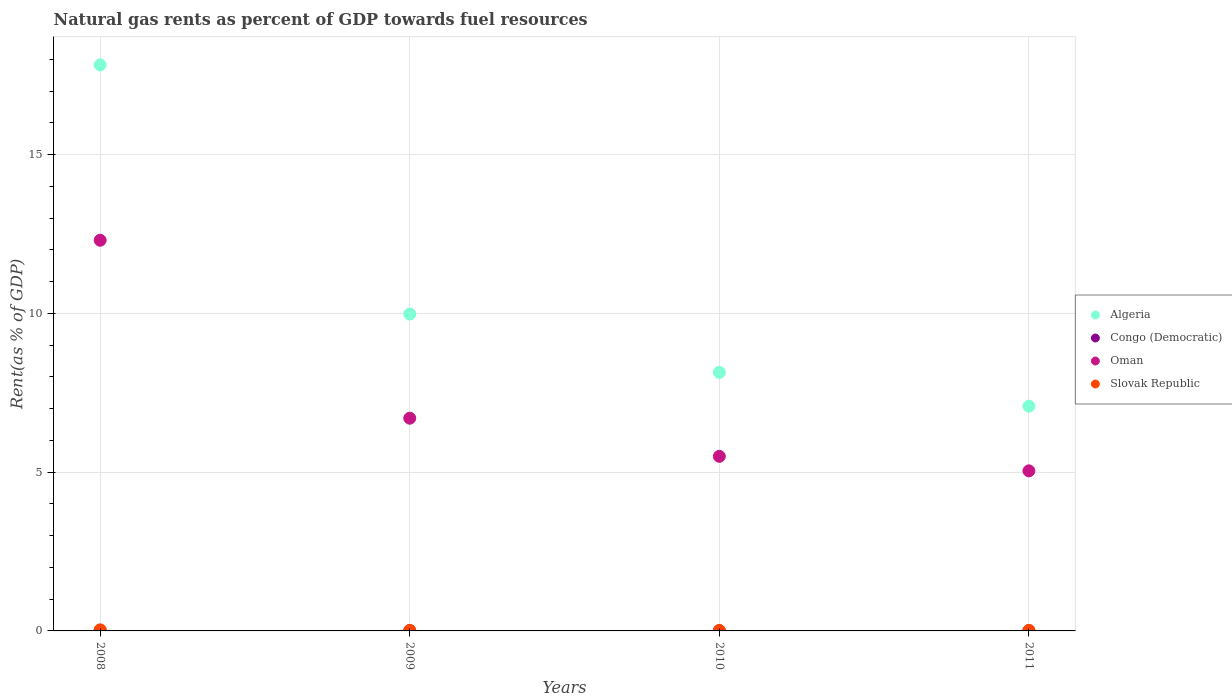What is the matural gas rent in Algeria in 2009?
Offer a very short reply. 9.98. Across all years, what is the maximum matural gas rent in Congo (Democratic)?
Ensure brevity in your answer.  0.02. Across all years, what is the minimum matural gas rent in Congo (Democratic)?
Ensure brevity in your answer.  0.01. In which year was the matural gas rent in Algeria minimum?
Your answer should be very brief. 2011. What is the total matural gas rent in Oman in the graph?
Make the answer very short. 29.54. What is the difference between the matural gas rent in Oman in 2008 and that in 2011?
Offer a very short reply. 7.26. What is the difference between the matural gas rent in Congo (Democratic) in 2011 and the matural gas rent in Algeria in 2008?
Give a very brief answer. -17.82. What is the average matural gas rent in Slovak Republic per year?
Your answer should be very brief. 0.02. In the year 2009, what is the difference between the matural gas rent in Slovak Republic and matural gas rent in Algeria?
Your answer should be compact. -9.96. In how many years, is the matural gas rent in Algeria greater than 1 %?
Provide a short and direct response. 4. What is the ratio of the matural gas rent in Congo (Democratic) in 2008 to that in 2011?
Make the answer very short. 2.58. Is the difference between the matural gas rent in Slovak Republic in 2008 and 2010 greater than the difference between the matural gas rent in Algeria in 2008 and 2010?
Keep it short and to the point. No. What is the difference between the highest and the second highest matural gas rent in Algeria?
Offer a terse response. 7.85. What is the difference between the highest and the lowest matural gas rent in Oman?
Give a very brief answer. 7.26. In how many years, is the matural gas rent in Congo (Democratic) greater than the average matural gas rent in Congo (Democratic) taken over all years?
Make the answer very short. 1. Does the matural gas rent in Congo (Democratic) monotonically increase over the years?
Your answer should be very brief. No. Is the matural gas rent in Oman strictly greater than the matural gas rent in Congo (Democratic) over the years?
Offer a terse response. Yes. Is the matural gas rent in Oman strictly less than the matural gas rent in Algeria over the years?
Your response must be concise. Yes. How many dotlines are there?
Your response must be concise. 4. What is the difference between two consecutive major ticks on the Y-axis?
Your answer should be very brief. 5. Are the values on the major ticks of Y-axis written in scientific E-notation?
Ensure brevity in your answer.  No. Does the graph contain any zero values?
Your response must be concise. No. Where does the legend appear in the graph?
Keep it short and to the point. Center right. What is the title of the graph?
Keep it short and to the point. Natural gas rents as percent of GDP towards fuel resources. What is the label or title of the X-axis?
Give a very brief answer. Years. What is the label or title of the Y-axis?
Offer a terse response. Rent(as % of GDP). What is the Rent(as % of GDP) in Algeria in 2008?
Make the answer very short. 17.82. What is the Rent(as % of GDP) in Congo (Democratic) in 2008?
Keep it short and to the point. 0.02. What is the Rent(as % of GDP) in Oman in 2008?
Offer a very short reply. 12.3. What is the Rent(as % of GDP) of Slovak Republic in 2008?
Provide a short and direct response. 0.03. What is the Rent(as % of GDP) of Algeria in 2009?
Your answer should be compact. 9.98. What is the Rent(as % of GDP) in Congo (Democratic) in 2009?
Provide a succinct answer. 0.01. What is the Rent(as % of GDP) in Oman in 2009?
Give a very brief answer. 6.7. What is the Rent(as % of GDP) in Slovak Republic in 2009?
Offer a very short reply. 0.02. What is the Rent(as % of GDP) in Algeria in 2010?
Keep it short and to the point. 8.14. What is the Rent(as % of GDP) in Congo (Democratic) in 2010?
Make the answer very short. 0.01. What is the Rent(as % of GDP) of Oman in 2010?
Provide a short and direct response. 5.5. What is the Rent(as % of GDP) of Slovak Republic in 2010?
Give a very brief answer. 0.01. What is the Rent(as % of GDP) in Algeria in 2011?
Ensure brevity in your answer.  7.08. What is the Rent(as % of GDP) in Congo (Democratic) in 2011?
Ensure brevity in your answer.  0.01. What is the Rent(as % of GDP) of Oman in 2011?
Offer a terse response. 5.04. What is the Rent(as % of GDP) in Slovak Republic in 2011?
Your answer should be compact. 0.02. Across all years, what is the maximum Rent(as % of GDP) of Algeria?
Your answer should be compact. 17.82. Across all years, what is the maximum Rent(as % of GDP) in Congo (Democratic)?
Ensure brevity in your answer.  0.02. Across all years, what is the maximum Rent(as % of GDP) in Oman?
Ensure brevity in your answer.  12.3. Across all years, what is the maximum Rent(as % of GDP) of Slovak Republic?
Offer a terse response. 0.03. Across all years, what is the minimum Rent(as % of GDP) of Algeria?
Your answer should be compact. 7.08. Across all years, what is the minimum Rent(as % of GDP) in Congo (Democratic)?
Make the answer very short. 0.01. Across all years, what is the minimum Rent(as % of GDP) of Oman?
Make the answer very short. 5.04. Across all years, what is the minimum Rent(as % of GDP) of Slovak Republic?
Your answer should be very brief. 0.01. What is the total Rent(as % of GDP) of Algeria in the graph?
Provide a succinct answer. 43.02. What is the total Rent(as % of GDP) of Congo (Democratic) in the graph?
Your answer should be very brief. 0.03. What is the total Rent(as % of GDP) of Oman in the graph?
Your response must be concise. 29.54. What is the total Rent(as % of GDP) in Slovak Republic in the graph?
Offer a terse response. 0.08. What is the difference between the Rent(as % of GDP) of Algeria in 2008 and that in 2009?
Provide a short and direct response. 7.85. What is the difference between the Rent(as % of GDP) of Congo (Democratic) in 2008 and that in 2009?
Provide a short and direct response. 0.01. What is the difference between the Rent(as % of GDP) of Oman in 2008 and that in 2009?
Provide a short and direct response. 5.6. What is the difference between the Rent(as % of GDP) in Slovak Republic in 2008 and that in 2009?
Make the answer very short. 0.02. What is the difference between the Rent(as % of GDP) in Algeria in 2008 and that in 2010?
Offer a terse response. 9.68. What is the difference between the Rent(as % of GDP) in Congo (Democratic) in 2008 and that in 2010?
Keep it short and to the point. 0.01. What is the difference between the Rent(as % of GDP) of Oman in 2008 and that in 2010?
Keep it short and to the point. 6.8. What is the difference between the Rent(as % of GDP) in Slovak Republic in 2008 and that in 2010?
Your answer should be very brief. 0.02. What is the difference between the Rent(as % of GDP) in Algeria in 2008 and that in 2011?
Provide a succinct answer. 10.75. What is the difference between the Rent(as % of GDP) of Congo (Democratic) in 2008 and that in 2011?
Offer a terse response. 0.01. What is the difference between the Rent(as % of GDP) of Oman in 2008 and that in 2011?
Provide a succinct answer. 7.26. What is the difference between the Rent(as % of GDP) in Slovak Republic in 2008 and that in 2011?
Offer a terse response. 0.02. What is the difference between the Rent(as % of GDP) of Algeria in 2009 and that in 2010?
Offer a terse response. 1.84. What is the difference between the Rent(as % of GDP) of Congo (Democratic) in 2009 and that in 2010?
Your answer should be compact. 0. What is the difference between the Rent(as % of GDP) of Oman in 2009 and that in 2010?
Give a very brief answer. 1.2. What is the difference between the Rent(as % of GDP) of Slovak Republic in 2009 and that in 2010?
Your answer should be compact. 0. What is the difference between the Rent(as % of GDP) of Algeria in 2009 and that in 2011?
Make the answer very short. 2.9. What is the difference between the Rent(as % of GDP) in Congo (Democratic) in 2009 and that in 2011?
Offer a terse response. 0. What is the difference between the Rent(as % of GDP) in Oman in 2009 and that in 2011?
Your answer should be compact. 1.66. What is the difference between the Rent(as % of GDP) in Slovak Republic in 2009 and that in 2011?
Offer a terse response. -0. What is the difference between the Rent(as % of GDP) of Algeria in 2010 and that in 2011?
Offer a very short reply. 1.06. What is the difference between the Rent(as % of GDP) of Congo (Democratic) in 2010 and that in 2011?
Ensure brevity in your answer.  0. What is the difference between the Rent(as % of GDP) in Oman in 2010 and that in 2011?
Give a very brief answer. 0.46. What is the difference between the Rent(as % of GDP) in Slovak Republic in 2010 and that in 2011?
Ensure brevity in your answer.  -0. What is the difference between the Rent(as % of GDP) of Algeria in 2008 and the Rent(as % of GDP) of Congo (Democratic) in 2009?
Offer a very short reply. 17.82. What is the difference between the Rent(as % of GDP) of Algeria in 2008 and the Rent(as % of GDP) of Oman in 2009?
Your answer should be very brief. 11.13. What is the difference between the Rent(as % of GDP) of Algeria in 2008 and the Rent(as % of GDP) of Slovak Republic in 2009?
Provide a succinct answer. 17.81. What is the difference between the Rent(as % of GDP) in Congo (Democratic) in 2008 and the Rent(as % of GDP) in Oman in 2009?
Your answer should be compact. -6.68. What is the difference between the Rent(as % of GDP) in Congo (Democratic) in 2008 and the Rent(as % of GDP) in Slovak Republic in 2009?
Keep it short and to the point. -0. What is the difference between the Rent(as % of GDP) of Oman in 2008 and the Rent(as % of GDP) of Slovak Republic in 2009?
Offer a terse response. 12.29. What is the difference between the Rent(as % of GDP) of Algeria in 2008 and the Rent(as % of GDP) of Congo (Democratic) in 2010?
Offer a terse response. 17.82. What is the difference between the Rent(as % of GDP) in Algeria in 2008 and the Rent(as % of GDP) in Oman in 2010?
Make the answer very short. 12.33. What is the difference between the Rent(as % of GDP) of Algeria in 2008 and the Rent(as % of GDP) of Slovak Republic in 2010?
Give a very brief answer. 17.81. What is the difference between the Rent(as % of GDP) in Congo (Democratic) in 2008 and the Rent(as % of GDP) in Oman in 2010?
Provide a succinct answer. -5.48. What is the difference between the Rent(as % of GDP) in Congo (Democratic) in 2008 and the Rent(as % of GDP) in Slovak Republic in 2010?
Provide a short and direct response. 0. What is the difference between the Rent(as % of GDP) of Oman in 2008 and the Rent(as % of GDP) of Slovak Republic in 2010?
Offer a terse response. 12.29. What is the difference between the Rent(as % of GDP) of Algeria in 2008 and the Rent(as % of GDP) of Congo (Democratic) in 2011?
Your response must be concise. 17.82. What is the difference between the Rent(as % of GDP) in Algeria in 2008 and the Rent(as % of GDP) in Oman in 2011?
Ensure brevity in your answer.  12.78. What is the difference between the Rent(as % of GDP) in Algeria in 2008 and the Rent(as % of GDP) in Slovak Republic in 2011?
Keep it short and to the point. 17.81. What is the difference between the Rent(as % of GDP) of Congo (Democratic) in 2008 and the Rent(as % of GDP) of Oman in 2011?
Make the answer very short. -5.03. What is the difference between the Rent(as % of GDP) of Congo (Democratic) in 2008 and the Rent(as % of GDP) of Slovak Republic in 2011?
Offer a very short reply. -0. What is the difference between the Rent(as % of GDP) of Oman in 2008 and the Rent(as % of GDP) of Slovak Republic in 2011?
Keep it short and to the point. 12.29. What is the difference between the Rent(as % of GDP) in Algeria in 2009 and the Rent(as % of GDP) in Congo (Democratic) in 2010?
Offer a very short reply. 9.97. What is the difference between the Rent(as % of GDP) of Algeria in 2009 and the Rent(as % of GDP) of Oman in 2010?
Your response must be concise. 4.48. What is the difference between the Rent(as % of GDP) in Algeria in 2009 and the Rent(as % of GDP) in Slovak Republic in 2010?
Offer a terse response. 9.96. What is the difference between the Rent(as % of GDP) in Congo (Democratic) in 2009 and the Rent(as % of GDP) in Oman in 2010?
Ensure brevity in your answer.  -5.49. What is the difference between the Rent(as % of GDP) of Congo (Democratic) in 2009 and the Rent(as % of GDP) of Slovak Republic in 2010?
Provide a short and direct response. -0.01. What is the difference between the Rent(as % of GDP) of Oman in 2009 and the Rent(as % of GDP) of Slovak Republic in 2010?
Provide a succinct answer. 6.68. What is the difference between the Rent(as % of GDP) of Algeria in 2009 and the Rent(as % of GDP) of Congo (Democratic) in 2011?
Offer a terse response. 9.97. What is the difference between the Rent(as % of GDP) of Algeria in 2009 and the Rent(as % of GDP) of Oman in 2011?
Give a very brief answer. 4.94. What is the difference between the Rent(as % of GDP) of Algeria in 2009 and the Rent(as % of GDP) of Slovak Republic in 2011?
Your response must be concise. 9.96. What is the difference between the Rent(as % of GDP) of Congo (Democratic) in 2009 and the Rent(as % of GDP) of Oman in 2011?
Offer a terse response. -5.03. What is the difference between the Rent(as % of GDP) in Congo (Democratic) in 2009 and the Rent(as % of GDP) in Slovak Republic in 2011?
Provide a short and direct response. -0.01. What is the difference between the Rent(as % of GDP) in Oman in 2009 and the Rent(as % of GDP) in Slovak Republic in 2011?
Make the answer very short. 6.68. What is the difference between the Rent(as % of GDP) of Algeria in 2010 and the Rent(as % of GDP) of Congo (Democratic) in 2011?
Offer a very short reply. 8.13. What is the difference between the Rent(as % of GDP) in Algeria in 2010 and the Rent(as % of GDP) in Oman in 2011?
Offer a very short reply. 3.1. What is the difference between the Rent(as % of GDP) of Algeria in 2010 and the Rent(as % of GDP) of Slovak Republic in 2011?
Keep it short and to the point. 8.12. What is the difference between the Rent(as % of GDP) of Congo (Democratic) in 2010 and the Rent(as % of GDP) of Oman in 2011?
Ensure brevity in your answer.  -5.03. What is the difference between the Rent(as % of GDP) of Congo (Democratic) in 2010 and the Rent(as % of GDP) of Slovak Republic in 2011?
Your answer should be compact. -0.01. What is the difference between the Rent(as % of GDP) in Oman in 2010 and the Rent(as % of GDP) in Slovak Republic in 2011?
Offer a terse response. 5.48. What is the average Rent(as % of GDP) of Algeria per year?
Provide a succinct answer. 10.76. What is the average Rent(as % of GDP) in Congo (Democratic) per year?
Provide a succinct answer. 0.01. What is the average Rent(as % of GDP) of Oman per year?
Provide a short and direct response. 7.38. What is the average Rent(as % of GDP) in Slovak Republic per year?
Ensure brevity in your answer.  0.02. In the year 2008, what is the difference between the Rent(as % of GDP) of Algeria and Rent(as % of GDP) of Congo (Democratic)?
Keep it short and to the point. 17.81. In the year 2008, what is the difference between the Rent(as % of GDP) in Algeria and Rent(as % of GDP) in Oman?
Ensure brevity in your answer.  5.52. In the year 2008, what is the difference between the Rent(as % of GDP) of Algeria and Rent(as % of GDP) of Slovak Republic?
Provide a short and direct response. 17.79. In the year 2008, what is the difference between the Rent(as % of GDP) of Congo (Democratic) and Rent(as % of GDP) of Oman?
Offer a very short reply. -12.29. In the year 2008, what is the difference between the Rent(as % of GDP) of Congo (Democratic) and Rent(as % of GDP) of Slovak Republic?
Offer a terse response. -0.02. In the year 2008, what is the difference between the Rent(as % of GDP) in Oman and Rent(as % of GDP) in Slovak Republic?
Your answer should be very brief. 12.27. In the year 2009, what is the difference between the Rent(as % of GDP) in Algeria and Rent(as % of GDP) in Congo (Democratic)?
Your answer should be compact. 9.97. In the year 2009, what is the difference between the Rent(as % of GDP) of Algeria and Rent(as % of GDP) of Oman?
Your answer should be compact. 3.28. In the year 2009, what is the difference between the Rent(as % of GDP) in Algeria and Rent(as % of GDP) in Slovak Republic?
Make the answer very short. 9.96. In the year 2009, what is the difference between the Rent(as % of GDP) in Congo (Democratic) and Rent(as % of GDP) in Oman?
Provide a short and direct response. -6.69. In the year 2009, what is the difference between the Rent(as % of GDP) in Congo (Democratic) and Rent(as % of GDP) in Slovak Republic?
Your answer should be very brief. -0.01. In the year 2009, what is the difference between the Rent(as % of GDP) in Oman and Rent(as % of GDP) in Slovak Republic?
Offer a terse response. 6.68. In the year 2010, what is the difference between the Rent(as % of GDP) in Algeria and Rent(as % of GDP) in Congo (Democratic)?
Offer a very short reply. 8.13. In the year 2010, what is the difference between the Rent(as % of GDP) of Algeria and Rent(as % of GDP) of Oman?
Offer a terse response. 2.64. In the year 2010, what is the difference between the Rent(as % of GDP) in Algeria and Rent(as % of GDP) in Slovak Republic?
Your answer should be very brief. 8.13. In the year 2010, what is the difference between the Rent(as % of GDP) in Congo (Democratic) and Rent(as % of GDP) in Oman?
Offer a very short reply. -5.49. In the year 2010, what is the difference between the Rent(as % of GDP) of Congo (Democratic) and Rent(as % of GDP) of Slovak Republic?
Your answer should be compact. -0.01. In the year 2010, what is the difference between the Rent(as % of GDP) of Oman and Rent(as % of GDP) of Slovak Republic?
Offer a terse response. 5.48. In the year 2011, what is the difference between the Rent(as % of GDP) in Algeria and Rent(as % of GDP) in Congo (Democratic)?
Offer a very short reply. 7.07. In the year 2011, what is the difference between the Rent(as % of GDP) of Algeria and Rent(as % of GDP) of Oman?
Your answer should be compact. 2.04. In the year 2011, what is the difference between the Rent(as % of GDP) of Algeria and Rent(as % of GDP) of Slovak Republic?
Make the answer very short. 7.06. In the year 2011, what is the difference between the Rent(as % of GDP) in Congo (Democratic) and Rent(as % of GDP) in Oman?
Give a very brief answer. -5.03. In the year 2011, what is the difference between the Rent(as % of GDP) in Congo (Democratic) and Rent(as % of GDP) in Slovak Republic?
Your answer should be very brief. -0.01. In the year 2011, what is the difference between the Rent(as % of GDP) of Oman and Rent(as % of GDP) of Slovak Republic?
Provide a short and direct response. 5.02. What is the ratio of the Rent(as % of GDP) of Algeria in 2008 to that in 2009?
Keep it short and to the point. 1.79. What is the ratio of the Rent(as % of GDP) of Congo (Democratic) in 2008 to that in 2009?
Your answer should be compact. 2.06. What is the ratio of the Rent(as % of GDP) in Oman in 2008 to that in 2009?
Offer a terse response. 1.84. What is the ratio of the Rent(as % of GDP) in Slovak Republic in 2008 to that in 2009?
Offer a very short reply. 2.11. What is the ratio of the Rent(as % of GDP) in Algeria in 2008 to that in 2010?
Keep it short and to the point. 2.19. What is the ratio of the Rent(as % of GDP) of Congo (Democratic) in 2008 to that in 2010?
Give a very brief answer. 2.46. What is the ratio of the Rent(as % of GDP) of Oman in 2008 to that in 2010?
Give a very brief answer. 2.24. What is the ratio of the Rent(as % of GDP) of Slovak Republic in 2008 to that in 2010?
Provide a short and direct response. 2.32. What is the ratio of the Rent(as % of GDP) in Algeria in 2008 to that in 2011?
Your response must be concise. 2.52. What is the ratio of the Rent(as % of GDP) in Congo (Democratic) in 2008 to that in 2011?
Your answer should be very brief. 2.58. What is the ratio of the Rent(as % of GDP) of Oman in 2008 to that in 2011?
Your response must be concise. 2.44. What is the ratio of the Rent(as % of GDP) of Slovak Republic in 2008 to that in 2011?
Provide a short and direct response. 2.01. What is the ratio of the Rent(as % of GDP) of Algeria in 2009 to that in 2010?
Offer a terse response. 1.23. What is the ratio of the Rent(as % of GDP) in Congo (Democratic) in 2009 to that in 2010?
Offer a terse response. 1.2. What is the ratio of the Rent(as % of GDP) in Oman in 2009 to that in 2010?
Your answer should be compact. 1.22. What is the ratio of the Rent(as % of GDP) of Slovak Republic in 2009 to that in 2010?
Give a very brief answer. 1.1. What is the ratio of the Rent(as % of GDP) in Algeria in 2009 to that in 2011?
Provide a short and direct response. 1.41. What is the ratio of the Rent(as % of GDP) in Congo (Democratic) in 2009 to that in 2011?
Provide a short and direct response. 1.25. What is the ratio of the Rent(as % of GDP) of Oman in 2009 to that in 2011?
Your answer should be compact. 1.33. What is the ratio of the Rent(as % of GDP) in Slovak Republic in 2009 to that in 2011?
Provide a succinct answer. 0.95. What is the ratio of the Rent(as % of GDP) of Algeria in 2010 to that in 2011?
Ensure brevity in your answer.  1.15. What is the ratio of the Rent(as % of GDP) of Congo (Democratic) in 2010 to that in 2011?
Make the answer very short. 1.05. What is the ratio of the Rent(as % of GDP) of Oman in 2010 to that in 2011?
Your response must be concise. 1.09. What is the ratio of the Rent(as % of GDP) in Slovak Republic in 2010 to that in 2011?
Give a very brief answer. 0.87. What is the difference between the highest and the second highest Rent(as % of GDP) of Algeria?
Your response must be concise. 7.85. What is the difference between the highest and the second highest Rent(as % of GDP) of Congo (Democratic)?
Keep it short and to the point. 0.01. What is the difference between the highest and the second highest Rent(as % of GDP) in Oman?
Ensure brevity in your answer.  5.6. What is the difference between the highest and the second highest Rent(as % of GDP) in Slovak Republic?
Offer a very short reply. 0.02. What is the difference between the highest and the lowest Rent(as % of GDP) of Algeria?
Give a very brief answer. 10.75. What is the difference between the highest and the lowest Rent(as % of GDP) of Congo (Democratic)?
Offer a terse response. 0.01. What is the difference between the highest and the lowest Rent(as % of GDP) in Oman?
Make the answer very short. 7.26. What is the difference between the highest and the lowest Rent(as % of GDP) of Slovak Republic?
Your answer should be compact. 0.02. 